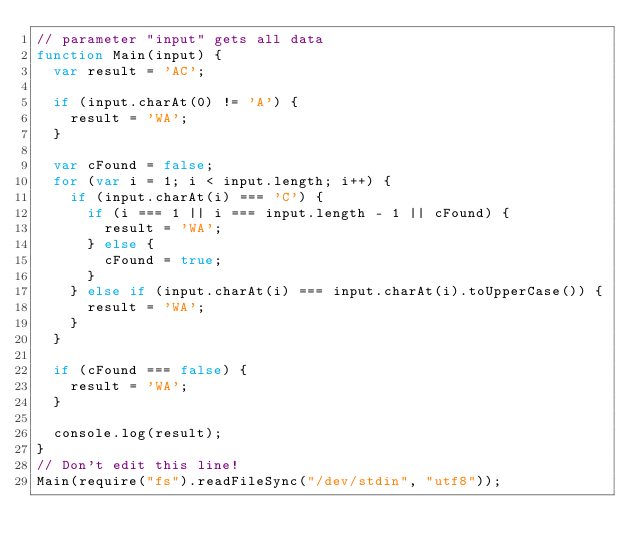Convert code to text. <code><loc_0><loc_0><loc_500><loc_500><_JavaScript_>// parameter "input" gets all data
function Main(input) {
  var result = 'AC';

  if (input.charAt(0) != 'A') {
    result = 'WA';
  }

  var cFound = false;
  for (var i = 1; i < input.length; i++) {
    if (input.charAt(i) === 'C') {
      if (i === 1 || i === input.length - 1 || cFound) {
        result = 'WA';
      } else {
        cFound = true;
      }
    } else if (input.charAt(i) === input.charAt(i).toUpperCase()) {
      result = 'WA';
    }
  }

  if (cFound === false) {
    result = 'WA';
  }

  console.log(result);
}
// Don't edit this line!
Main(require("fs").readFileSync("/dev/stdin", "utf8"));
</code> 